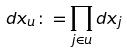<formula> <loc_0><loc_0><loc_500><loc_500>d x _ { u } \colon = \prod _ { j \in u } d x _ { j }</formula> 